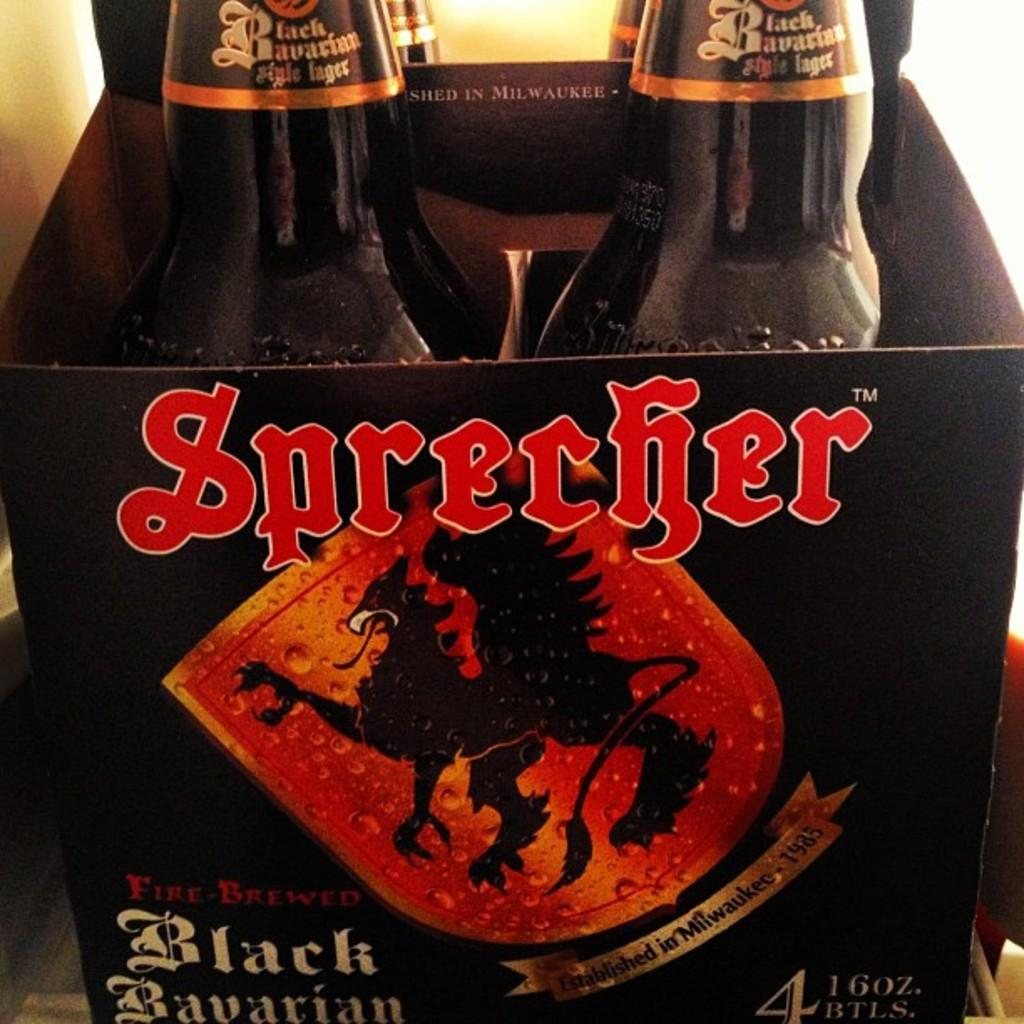Provide a one-sentence caption for the provided image. A four pack of Sprecher black Bavarian beer. 